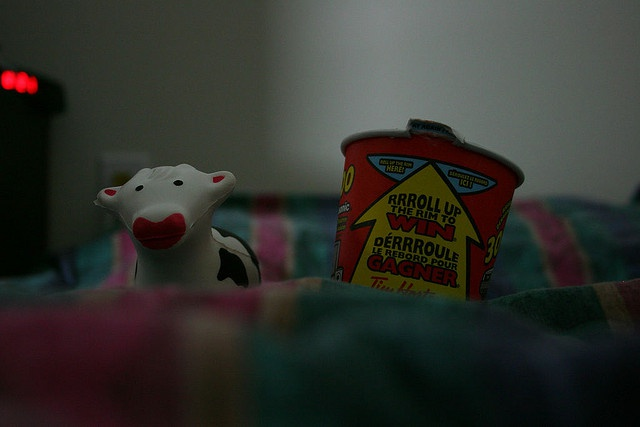Describe the objects in this image and their specific colors. I can see a cow in black, gray, and maroon tones in this image. 